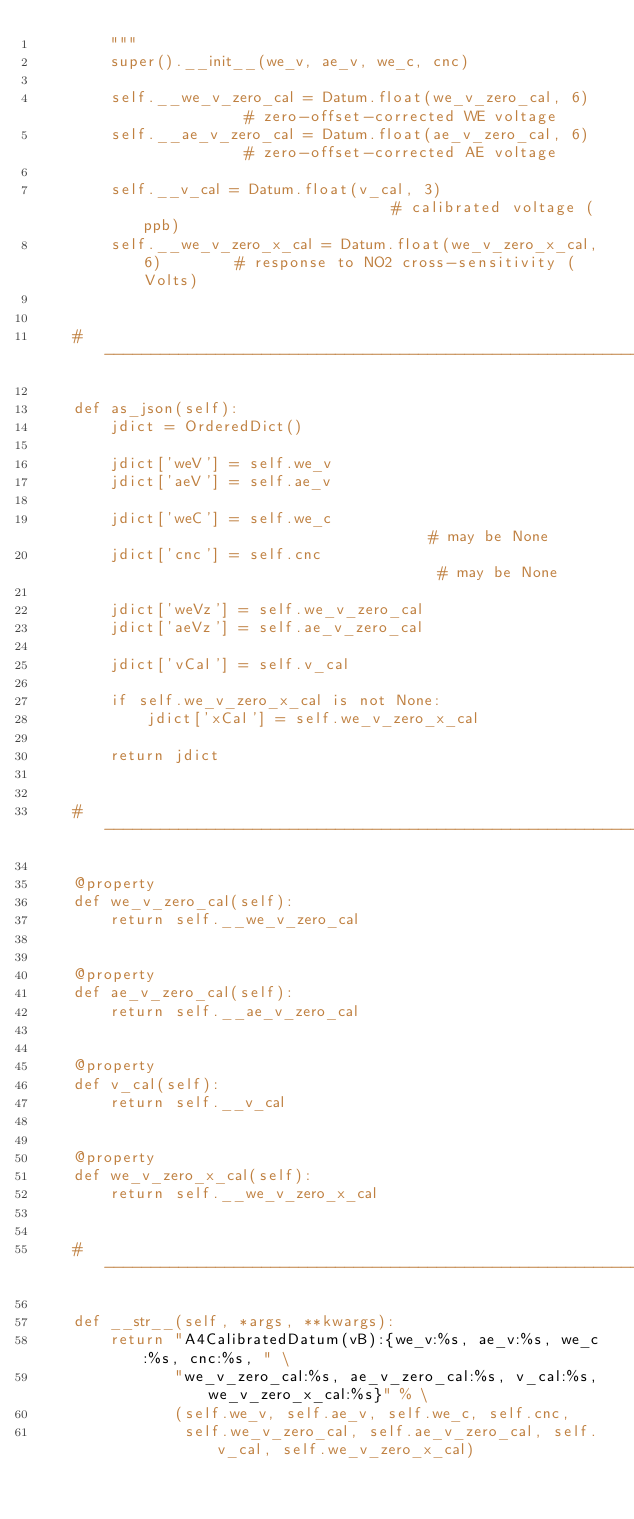Convert code to text. <code><loc_0><loc_0><loc_500><loc_500><_Python_>        """
        super().__init__(we_v, ae_v, we_c, cnc)

        self.__we_v_zero_cal = Datum.float(we_v_zero_cal, 6)            # zero-offset-corrected WE voltage
        self.__ae_v_zero_cal = Datum.float(ae_v_zero_cal, 6)            # zero-offset-corrected AE voltage

        self.__v_cal = Datum.float(v_cal, 3)                            # calibrated voltage (ppb)
        self.__we_v_zero_x_cal = Datum.float(we_v_zero_x_cal, 6)        # response to NO2 cross-sensitivity (Volts)


    # ----------------------------------------------------------------------------------------------------------------

    def as_json(self):
        jdict = OrderedDict()

        jdict['weV'] = self.we_v
        jdict['aeV'] = self.ae_v

        jdict['weC'] = self.we_c                                # may be None
        jdict['cnc'] = self.cnc                                 # may be None

        jdict['weVz'] = self.we_v_zero_cal
        jdict['aeVz'] = self.ae_v_zero_cal

        jdict['vCal'] = self.v_cal

        if self.we_v_zero_x_cal is not None:
            jdict['xCal'] = self.we_v_zero_x_cal

        return jdict


    # ----------------------------------------------------------------------------------------------------------------

    @property
    def we_v_zero_cal(self):
        return self.__we_v_zero_cal


    @property
    def ae_v_zero_cal(self):
        return self.__ae_v_zero_cal


    @property
    def v_cal(self):
        return self.__v_cal


    @property
    def we_v_zero_x_cal(self):
        return self.__we_v_zero_x_cal


    # ----------------------------------------------------------------------------------------------------------------

    def __str__(self, *args, **kwargs):
        return "A4CalibratedDatum(vB):{we_v:%s, ae_v:%s, we_c:%s, cnc:%s, " \
               "we_v_zero_cal:%s, ae_v_zero_cal:%s, v_cal:%s, we_v_zero_x_cal:%s}" % \
               (self.we_v, self.ae_v, self.we_c, self.cnc,
                self.we_v_zero_cal, self.ae_v_zero_cal, self.v_cal, self.we_v_zero_x_cal)
</code> 